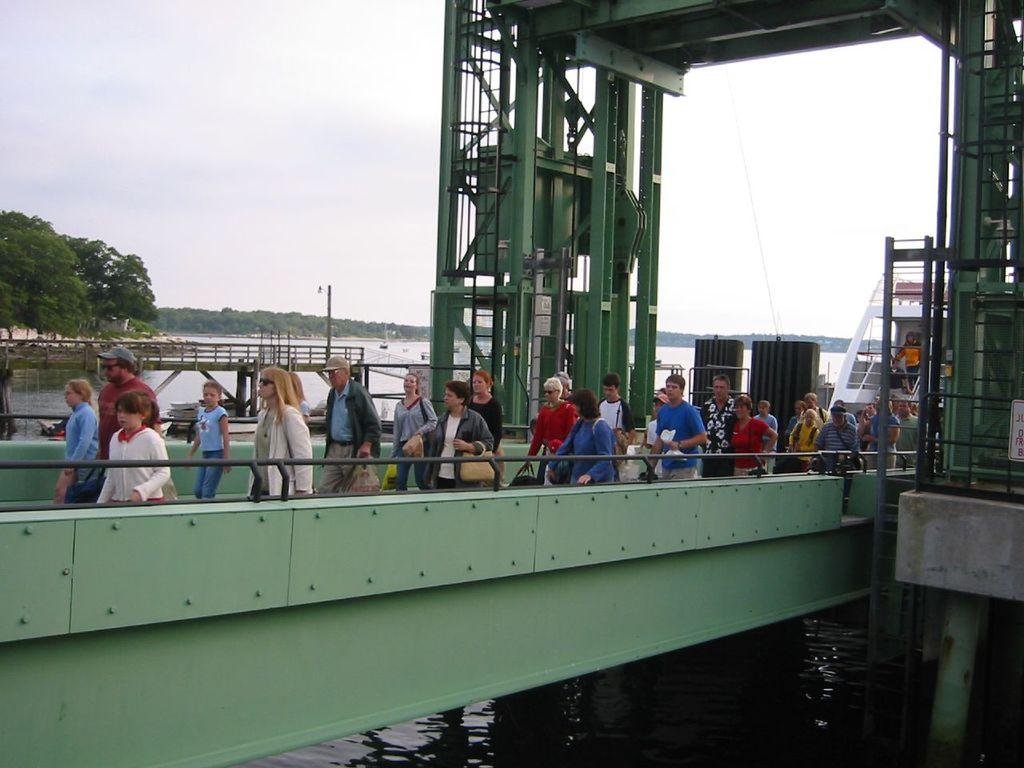How many people are in the group visible in the image? There is a group of people in the image, but the exact number cannot be determined from the provided facts. What structure can be seen in the image? There is a bridge in the image. What objects are present in the image that might be used for support or construction? There are rods, poles, and pillars in the image. What natural elements are visible in the image? There is water and trees in the image. What is visible in the background of the image? The sky is visible in the background of the image. Where is the lunchroom located in the image? There is no mention of a lunchroom in the image or the provided facts. What type of heart-shaped object can be seen in the image? There is no heart-shaped object present in the image. 